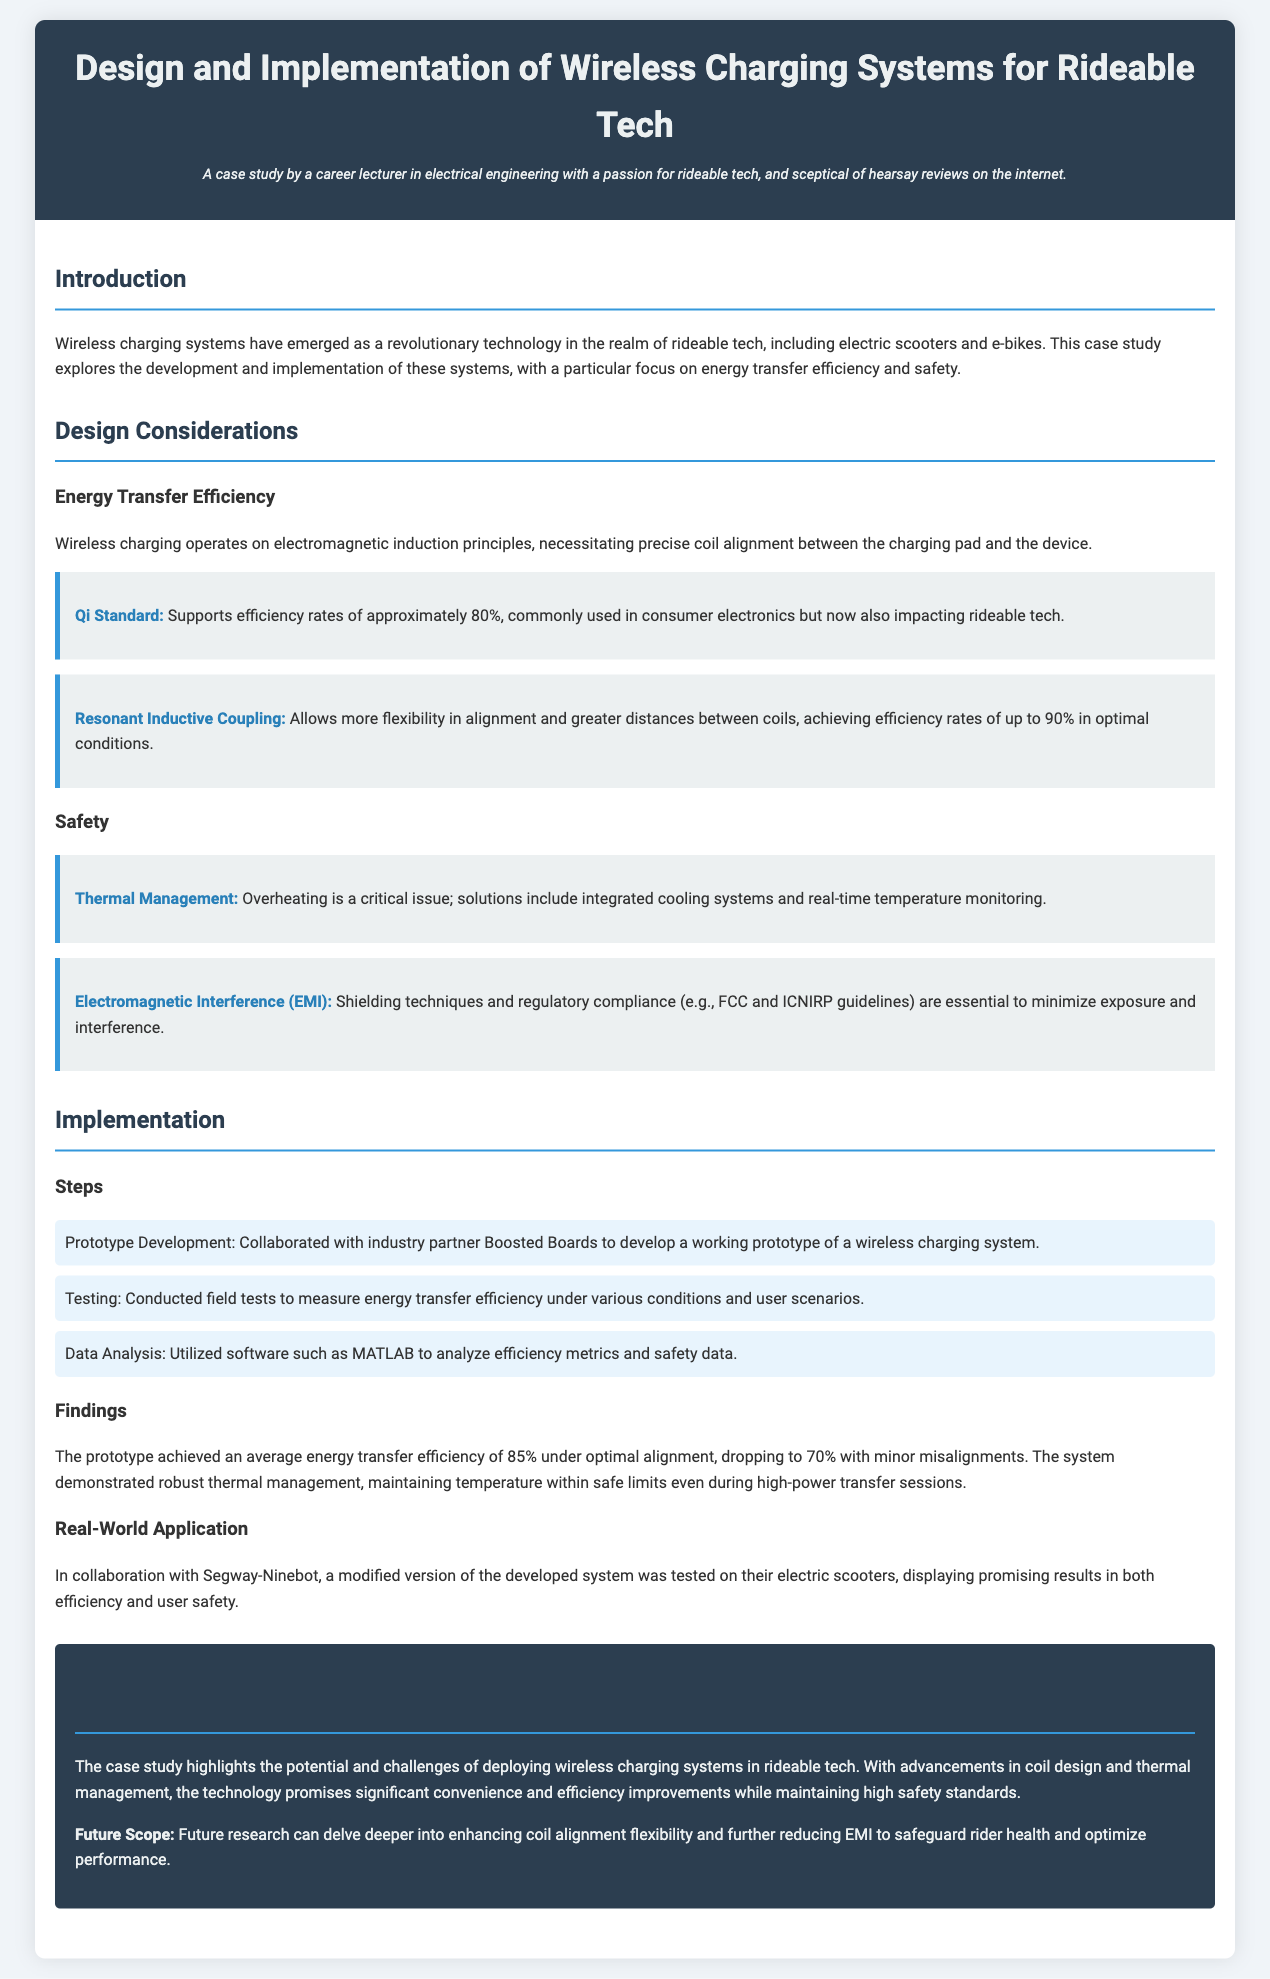What are the rideable tech examples mentioned? The document cites electric scooters and e-bikes as examples of rideable tech.
Answer: electric scooters, e-bikes What is the efficiency rate of the Qi Standard? The Qi Standard supports efficiency rates of approximately 80%.
Answer: approximately 80% What is a key solution for thermal management? The document mentions integrated cooling systems as a critical solution for thermal management.
Answer: integrated cooling systems How much efficiency does resonant inductive coupling achieve? The resonant inductive coupling achieves efficiency rates of up to 90% in optimal conditions.
Answer: up to 90% What was the average energy transfer efficiency of the prototype? The prototype achieved an average energy transfer efficiency of 85% under optimal alignment.
Answer: 85% Who did the prototype development collaborate with? The collaboration for prototype development was with industry partner Boosted Boards.
Answer: Boosted Boards What are the guidelines mentioned for minimizing electromagnetic interference? The document refers to FCC and ICNIRP guidelines as essential for minimizing electromagnetic interference.
Answer: FCC and ICNIRP What future scope does the case study suggest? The future scope suggested includes enhancing coil alignment flexibility and reducing electromagnetic interference.
Answer: enhancing coil alignment flexibility, reducing EMI What type of testing was conducted on scooters? The document states that a modified version of the developed system was tested on electric scooters.
Answer: tested on electric scooters 